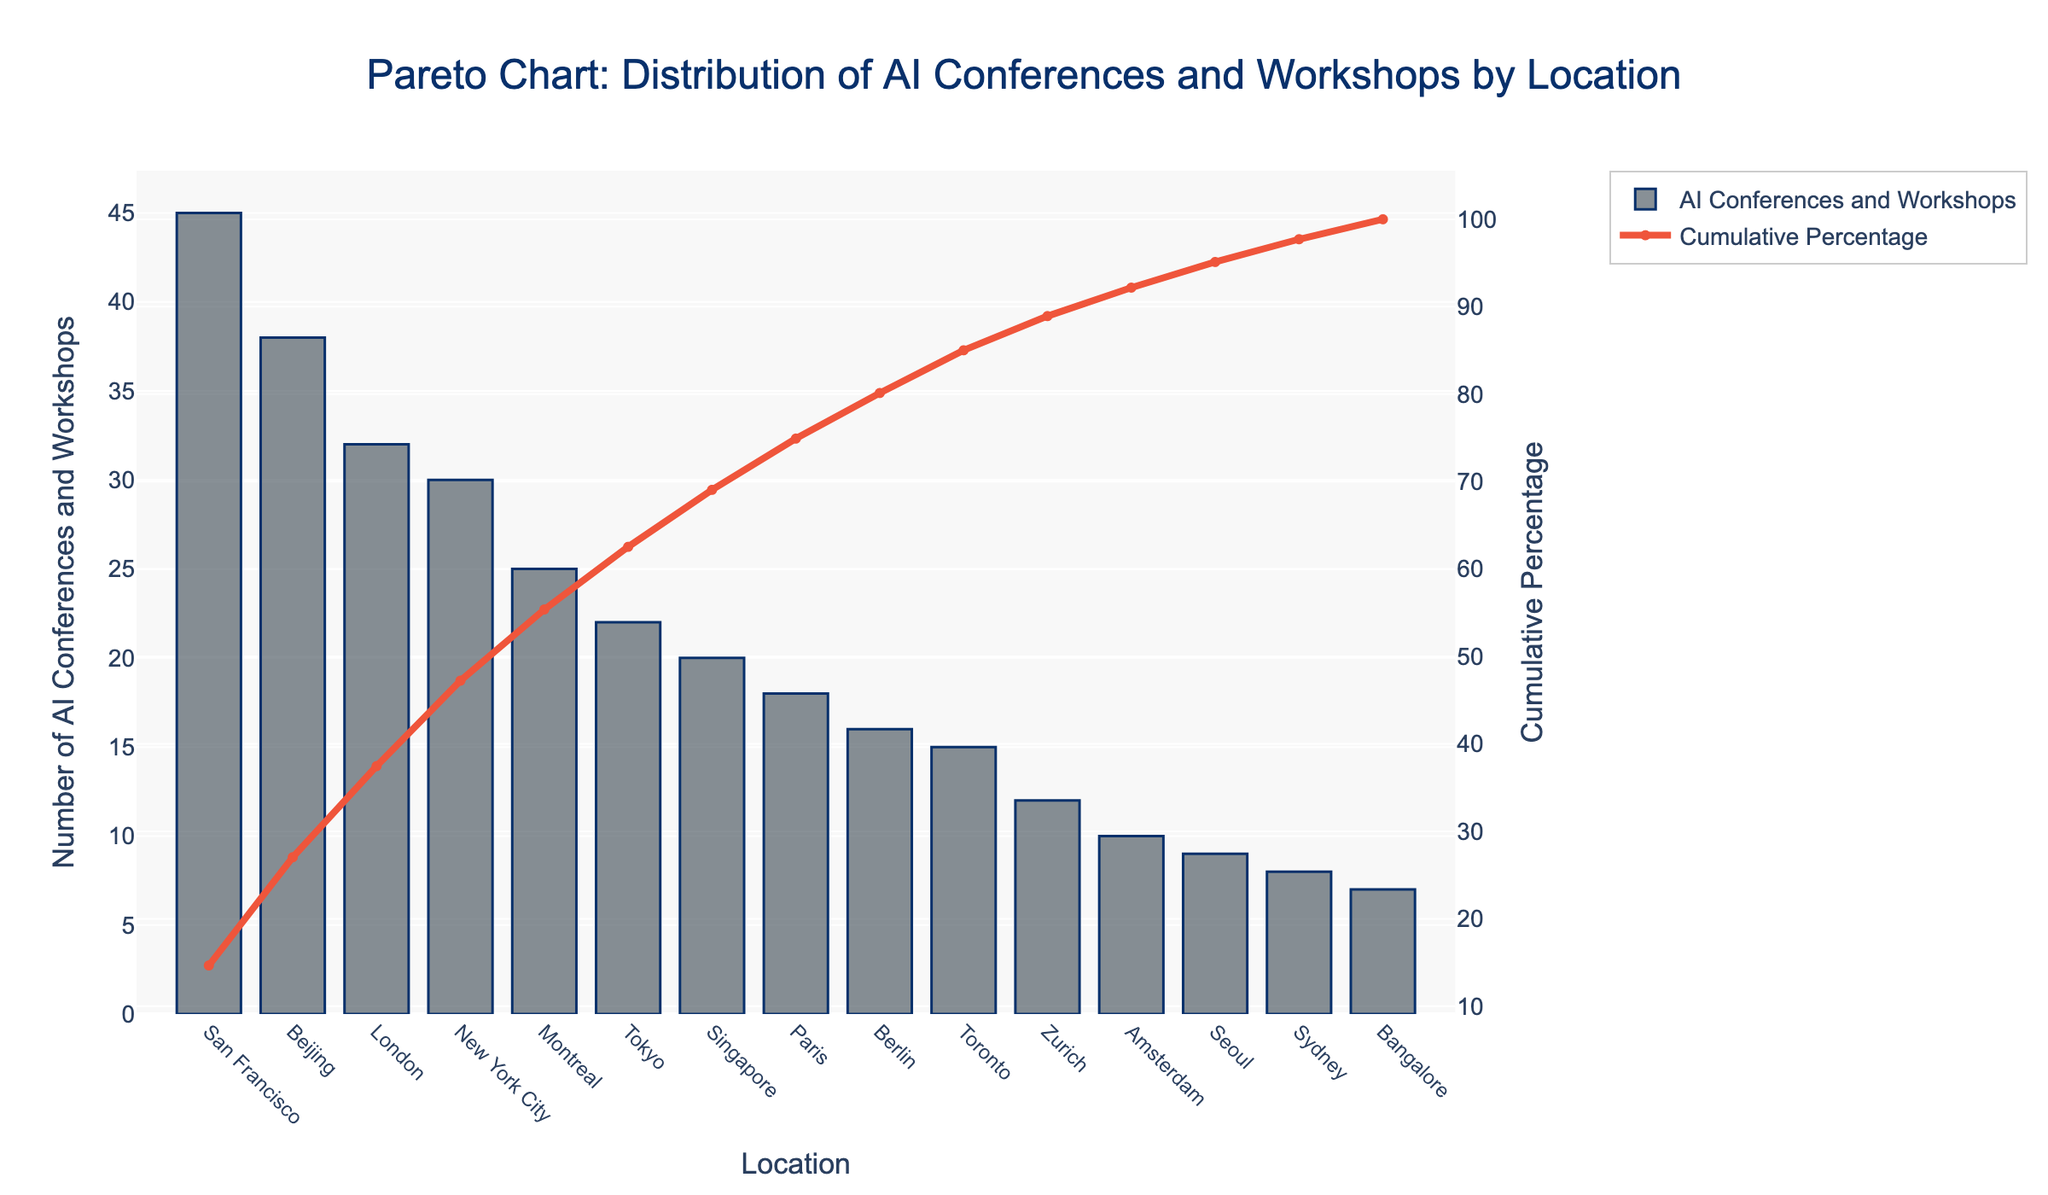What's the color of the bars representing the number of AI conferences and workshops? The color of the bars can be determined by observing the plot. The bars are colored in a shade of grey with a darker outline.
Answer: Grey What is the title of the Pareto chart? The title is written at the top center of the plot in a large font and it reads: "Pareto Chart: Distribution of AI Conferences and Workshops by Location"
Answer: Pareto Chart: Distribution of AI Conferences and Workshops by Location Which locations host more than 30 AI conferences and workshops? By looking at the bar heights and their corresponding x-axis labels, locations with bars extending higher than the 30-mark include San Francisco, Beijing, London, and New York City.
Answer: San Francisco, Beijing, London, New York City What percentage of AI conferences and workshops are held in the top 3 locations? By looking at the cumulative percentage line, the top three locations (San Francisco, Beijing, London) show cumulative percentages of approximately 12%, 24%, and 34% respectively. Summing these gives us approximately 34%.
Answer: 34% Which location has the highest number of AI conferences and workshops? The tallest bar represents the location with the highest number of AI conferences and workshops. This bar corresponds to San Francisco.
Answer: San Francisco How many AI conferences and workshops are held in Toronto? By observing the height of the bar corresponding to Toronto on the x-axis, we can see it reaches the 15 mark.
Answer: 15 Is the cumulative percentage line monotonically increasing? A quick glance at the line chart shows that the cumulative percentage consistently increases as you move from left to right. This indicates it is monotonically increasing.
Answer: Yes How many locations host fewer than 10 AI conferences and workshops each? Bars representing fewer than 10 conferences and workshops can be found towards the right end of the chart. These include Zurich, Amsterdam, Seoul, Sydney, and Bangalore. Counting them gives us 5 locations.
Answer: 5 What is the approximate cumulative percentage after the top 5 locations? The top 5 locations include San Francisco, Beijing, London, New York City, and Montreal. Observing where Montreal is on the cumulative percentage line, it is approximately at the 70% mark.
Answer: 70% How does the number of AI conferences and workshops in Tokyo compare to New York City? By comparing the heights of the bars for Tokyo and New York City, we see that New York City's bar is taller than Tokyo's. Specifically, New York City has 30 and Tokyo has 22.
Answer: New York City has more 